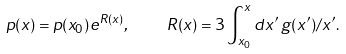Convert formula to latex. <formula><loc_0><loc_0><loc_500><loc_500>p ( x ) = p ( x _ { 0 } ) e ^ { R ( x ) } , \quad R ( x ) = 3 \int ^ { x } _ { x _ { 0 } } d x ^ { \prime } \, g ( x ^ { \prime } ) / x ^ { \prime } .</formula> 